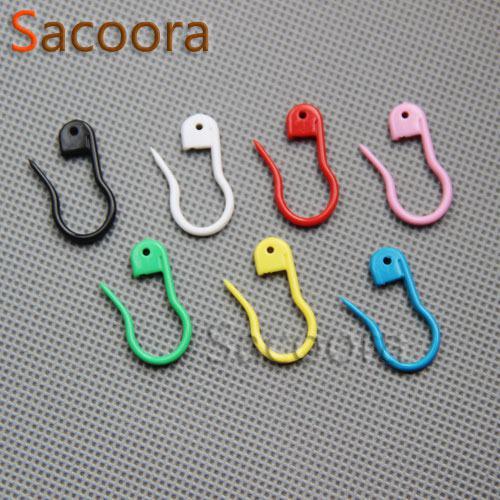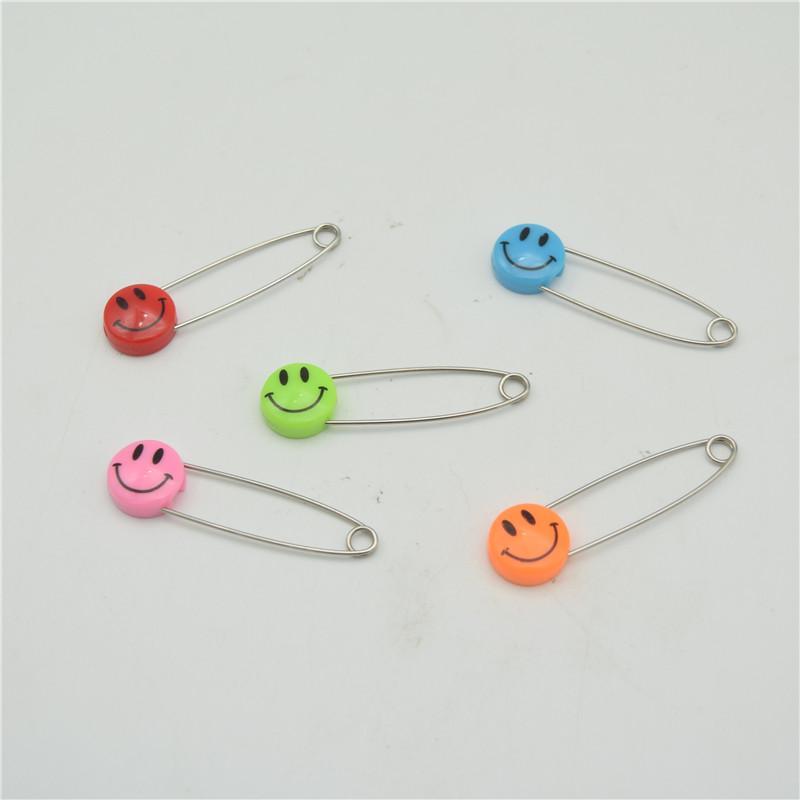The first image is the image on the left, the second image is the image on the right. Given the left and right images, does the statement "One image shows only two safety pins, one pink and one blue." hold true? Answer yes or no. No. 